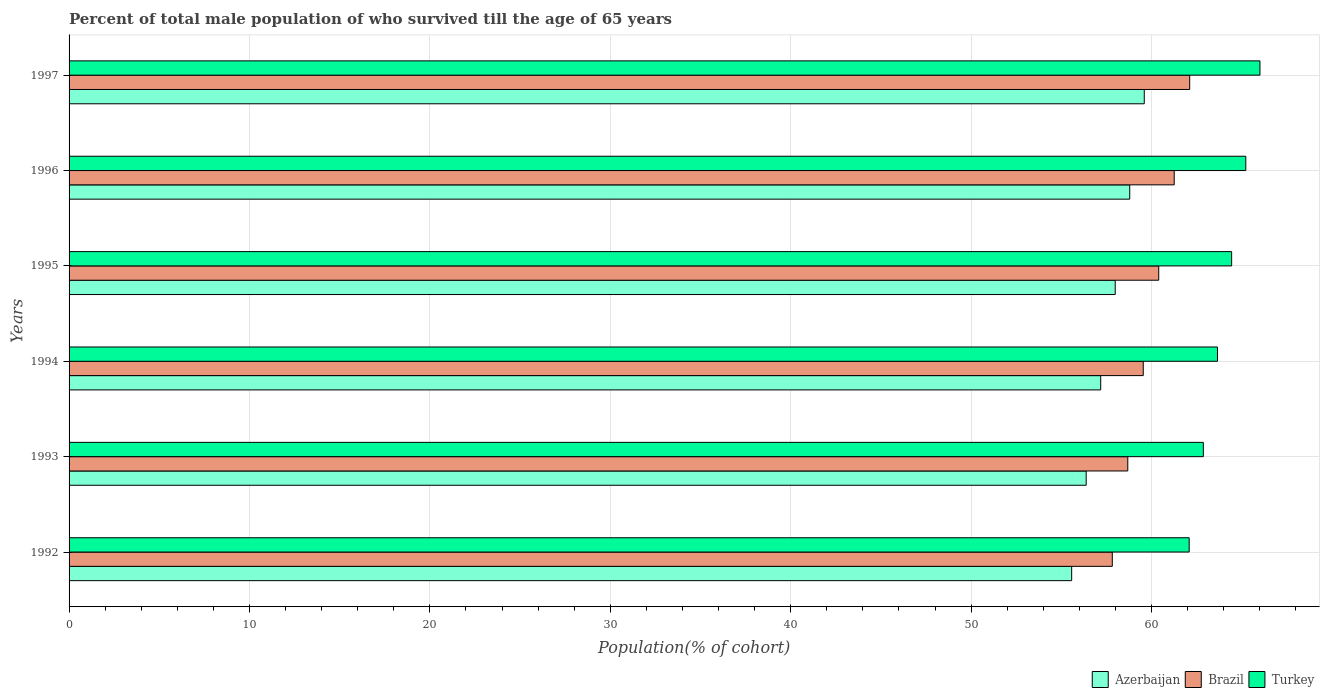How many different coloured bars are there?
Your response must be concise. 3. Are the number of bars per tick equal to the number of legend labels?
Make the answer very short. Yes. What is the percentage of total male population who survived till the age of 65 years in Brazil in 1993?
Ensure brevity in your answer.  58.68. Across all years, what is the maximum percentage of total male population who survived till the age of 65 years in Brazil?
Your answer should be compact. 62.12. Across all years, what is the minimum percentage of total male population who survived till the age of 65 years in Azerbaijan?
Your answer should be compact. 55.57. In which year was the percentage of total male population who survived till the age of 65 years in Azerbaijan maximum?
Provide a short and direct response. 1997. In which year was the percentage of total male population who survived till the age of 65 years in Azerbaijan minimum?
Keep it short and to the point. 1992. What is the total percentage of total male population who survived till the age of 65 years in Azerbaijan in the graph?
Offer a terse response. 345.51. What is the difference between the percentage of total male population who survived till the age of 65 years in Turkey in 1993 and that in 1996?
Offer a terse response. -2.35. What is the difference between the percentage of total male population who survived till the age of 65 years in Azerbaijan in 1992 and the percentage of total male population who survived till the age of 65 years in Turkey in 1996?
Provide a succinct answer. -9.65. What is the average percentage of total male population who survived till the age of 65 years in Azerbaijan per year?
Your answer should be very brief. 57.59. In the year 1994, what is the difference between the percentage of total male population who survived till the age of 65 years in Turkey and percentage of total male population who survived till the age of 65 years in Brazil?
Give a very brief answer. 4.11. What is the ratio of the percentage of total male population who survived till the age of 65 years in Brazil in 1994 to that in 1997?
Keep it short and to the point. 0.96. What is the difference between the highest and the second highest percentage of total male population who survived till the age of 65 years in Azerbaijan?
Offer a very short reply. 0.8. What is the difference between the highest and the lowest percentage of total male population who survived till the age of 65 years in Brazil?
Provide a succinct answer. 4.29. What does the 1st bar from the top in 1993 represents?
Your response must be concise. Turkey. What does the 2nd bar from the bottom in 1993 represents?
Provide a short and direct response. Brazil. Is it the case that in every year, the sum of the percentage of total male population who survived till the age of 65 years in Brazil and percentage of total male population who survived till the age of 65 years in Turkey is greater than the percentage of total male population who survived till the age of 65 years in Azerbaijan?
Ensure brevity in your answer.  Yes. What is the difference between two consecutive major ticks on the X-axis?
Keep it short and to the point. 10. Where does the legend appear in the graph?
Offer a terse response. Bottom right. What is the title of the graph?
Your response must be concise. Percent of total male population of who survived till the age of 65 years. Does "Korea (Republic)" appear as one of the legend labels in the graph?
Your response must be concise. No. What is the label or title of the X-axis?
Keep it short and to the point. Population(% of cohort). What is the Population(% of cohort) of Azerbaijan in 1992?
Give a very brief answer. 55.57. What is the Population(% of cohort) of Brazil in 1992?
Provide a short and direct response. 57.83. What is the Population(% of cohort) in Turkey in 1992?
Keep it short and to the point. 62.09. What is the Population(% of cohort) of Azerbaijan in 1993?
Provide a short and direct response. 56.38. What is the Population(% of cohort) in Brazil in 1993?
Make the answer very short. 58.68. What is the Population(% of cohort) of Turkey in 1993?
Your answer should be very brief. 62.87. What is the Population(% of cohort) of Azerbaijan in 1994?
Provide a short and direct response. 57.18. What is the Population(% of cohort) in Brazil in 1994?
Ensure brevity in your answer.  59.54. What is the Population(% of cohort) in Turkey in 1994?
Keep it short and to the point. 63.66. What is the Population(% of cohort) of Azerbaijan in 1995?
Make the answer very short. 57.99. What is the Population(% of cohort) in Brazil in 1995?
Keep it short and to the point. 60.4. What is the Population(% of cohort) in Turkey in 1995?
Your response must be concise. 64.44. What is the Population(% of cohort) in Azerbaijan in 1996?
Your answer should be compact. 58.79. What is the Population(% of cohort) of Brazil in 1996?
Offer a terse response. 61.26. What is the Population(% of cohort) in Turkey in 1996?
Provide a short and direct response. 65.23. What is the Population(% of cohort) of Azerbaijan in 1997?
Offer a terse response. 59.6. What is the Population(% of cohort) of Brazil in 1997?
Offer a very short reply. 62.12. What is the Population(% of cohort) of Turkey in 1997?
Offer a terse response. 66.01. Across all years, what is the maximum Population(% of cohort) of Azerbaijan?
Your answer should be compact. 59.6. Across all years, what is the maximum Population(% of cohort) in Brazil?
Give a very brief answer. 62.12. Across all years, what is the maximum Population(% of cohort) of Turkey?
Provide a succinct answer. 66.01. Across all years, what is the minimum Population(% of cohort) of Azerbaijan?
Your answer should be very brief. 55.57. Across all years, what is the minimum Population(% of cohort) of Brazil?
Make the answer very short. 57.83. Across all years, what is the minimum Population(% of cohort) in Turkey?
Provide a succinct answer. 62.09. What is the total Population(% of cohort) in Azerbaijan in the graph?
Your response must be concise. 345.51. What is the total Population(% of cohort) in Brazil in the graph?
Make the answer very short. 359.82. What is the total Population(% of cohort) in Turkey in the graph?
Your response must be concise. 384.29. What is the difference between the Population(% of cohort) of Azerbaijan in 1992 and that in 1993?
Offer a terse response. -0.8. What is the difference between the Population(% of cohort) of Brazil in 1992 and that in 1993?
Keep it short and to the point. -0.86. What is the difference between the Population(% of cohort) of Turkey in 1992 and that in 1993?
Your answer should be compact. -0.78. What is the difference between the Population(% of cohort) of Azerbaijan in 1992 and that in 1994?
Make the answer very short. -1.61. What is the difference between the Population(% of cohort) of Brazil in 1992 and that in 1994?
Your answer should be very brief. -1.72. What is the difference between the Population(% of cohort) of Turkey in 1992 and that in 1994?
Make the answer very short. -1.57. What is the difference between the Population(% of cohort) in Azerbaijan in 1992 and that in 1995?
Your answer should be very brief. -2.41. What is the difference between the Population(% of cohort) in Brazil in 1992 and that in 1995?
Make the answer very short. -2.57. What is the difference between the Population(% of cohort) in Turkey in 1992 and that in 1995?
Keep it short and to the point. -2.35. What is the difference between the Population(% of cohort) in Azerbaijan in 1992 and that in 1996?
Keep it short and to the point. -3.22. What is the difference between the Population(% of cohort) in Brazil in 1992 and that in 1996?
Give a very brief answer. -3.43. What is the difference between the Population(% of cohort) of Turkey in 1992 and that in 1996?
Provide a succinct answer. -3.14. What is the difference between the Population(% of cohort) of Azerbaijan in 1992 and that in 1997?
Give a very brief answer. -4.02. What is the difference between the Population(% of cohort) of Brazil in 1992 and that in 1997?
Offer a very short reply. -4.29. What is the difference between the Population(% of cohort) of Turkey in 1992 and that in 1997?
Give a very brief answer. -3.92. What is the difference between the Population(% of cohort) in Azerbaijan in 1993 and that in 1994?
Provide a succinct answer. -0.8. What is the difference between the Population(% of cohort) of Brazil in 1993 and that in 1994?
Your response must be concise. -0.86. What is the difference between the Population(% of cohort) of Turkey in 1993 and that in 1994?
Offer a terse response. -0.78. What is the difference between the Population(% of cohort) in Azerbaijan in 1993 and that in 1995?
Keep it short and to the point. -1.61. What is the difference between the Population(% of cohort) in Brazil in 1993 and that in 1995?
Provide a succinct answer. -1.72. What is the difference between the Population(% of cohort) of Turkey in 1993 and that in 1995?
Keep it short and to the point. -1.57. What is the difference between the Population(% of cohort) of Azerbaijan in 1993 and that in 1996?
Provide a short and direct response. -2.41. What is the difference between the Population(% of cohort) of Brazil in 1993 and that in 1996?
Keep it short and to the point. -2.57. What is the difference between the Population(% of cohort) in Turkey in 1993 and that in 1996?
Your response must be concise. -2.35. What is the difference between the Population(% of cohort) in Azerbaijan in 1993 and that in 1997?
Keep it short and to the point. -3.22. What is the difference between the Population(% of cohort) of Brazil in 1993 and that in 1997?
Give a very brief answer. -3.43. What is the difference between the Population(% of cohort) of Turkey in 1993 and that in 1997?
Make the answer very short. -3.14. What is the difference between the Population(% of cohort) in Azerbaijan in 1994 and that in 1995?
Offer a terse response. -0.8. What is the difference between the Population(% of cohort) of Brazil in 1994 and that in 1995?
Ensure brevity in your answer.  -0.86. What is the difference between the Population(% of cohort) in Turkey in 1994 and that in 1995?
Give a very brief answer. -0.78. What is the difference between the Population(% of cohort) in Azerbaijan in 1994 and that in 1996?
Provide a succinct answer. -1.61. What is the difference between the Population(% of cohort) in Brazil in 1994 and that in 1996?
Your answer should be compact. -1.72. What is the difference between the Population(% of cohort) of Turkey in 1994 and that in 1996?
Your response must be concise. -1.57. What is the difference between the Population(% of cohort) in Azerbaijan in 1994 and that in 1997?
Offer a terse response. -2.41. What is the difference between the Population(% of cohort) in Brazil in 1994 and that in 1997?
Your response must be concise. -2.57. What is the difference between the Population(% of cohort) in Turkey in 1994 and that in 1997?
Provide a succinct answer. -2.35. What is the difference between the Population(% of cohort) in Azerbaijan in 1995 and that in 1996?
Give a very brief answer. -0.8. What is the difference between the Population(% of cohort) of Brazil in 1995 and that in 1996?
Keep it short and to the point. -0.86. What is the difference between the Population(% of cohort) in Turkey in 1995 and that in 1996?
Your answer should be compact. -0.78. What is the difference between the Population(% of cohort) in Azerbaijan in 1995 and that in 1997?
Keep it short and to the point. -1.61. What is the difference between the Population(% of cohort) of Brazil in 1995 and that in 1997?
Provide a succinct answer. -1.72. What is the difference between the Population(% of cohort) of Turkey in 1995 and that in 1997?
Provide a short and direct response. -1.57. What is the difference between the Population(% of cohort) in Azerbaijan in 1996 and that in 1997?
Your response must be concise. -0.8. What is the difference between the Population(% of cohort) of Brazil in 1996 and that in 1997?
Provide a succinct answer. -0.86. What is the difference between the Population(% of cohort) in Turkey in 1996 and that in 1997?
Make the answer very short. -0.78. What is the difference between the Population(% of cohort) in Azerbaijan in 1992 and the Population(% of cohort) in Brazil in 1993?
Offer a terse response. -3.11. What is the difference between the Population(% of cohort) in Azerbaijan in 1992 and the Population(% of cohort) in Turkey in 1993?
Provide a short and direct response. -7.3. What is the difference between the Population(% of cohort) of Brazil in 1992 and the Population(% of cohort) of Turkey in 1993?
Your answer should be compact. -5.05. What is the difference between the Population(% of cohort) of Azerbaijan in 1992 and the Population(% of cohort) of Brazil in 1994?
Offer a very short reply. -3.97. What is the difference between the Population(% of cohort) of Azerbaijan in 1992 and the Population(% of cohort) of Turkey in 1994?
Make the answer very short. -8.08. What is the difference between the Population(% of cohort) in Brazil in 1992 and the Population(% of cohort) in Turkey in 1994?
Provide a succinct answer. -5.83. What is the difference between the Population(% of cohort) in Azerbaijan in 1992 and the Population(% of cohort) in Brazil in 1995?
Your answer should be compact. -4.83. What is the difference between the Population(% of cohort) in Azerbaijan in 1992 and the Population(% of cohort) in Turkey in 1995?
Ensure brevity in your answer.  -8.87. What is the difference between the Population(% of cohort) of Brazil in 1992 and the Population(% of cohort) of Turkey in 1995?
Give a very brief answer. -6.62. What is the difference between the Population(% of cohort) of Azerbaijan in 1992 and the Population(% of cohort) of Brazil in 1996?
Ensure brevity in your answer.  -5.68. What is the difference between the Population(% of cohort) of Azerbaijan in 1992 and the Population(% of cohort) of Turkey in 1996?
Ensure brevity in your answer.  -9.65. What is the difference between the Population(% of cohort) of Brazil in 1992 and the Population(% of cohort) of Turkey in 1996?
Keep it short and to the point. -7.4. What is the difference between the Population(% of cohort) in Azerbaijan in 1992 and the Population(% of cohort) in Brazil in 1997?
Offer a terse response. -6.54. What is the difference between the Population(% of cohort) of Azerbaijan in 1992 and the Population(% of cohort) of Turkey in 1997?
Provide a succinct answer. -10.44. What is the difference between the Population(% of cohort) in Brazil in 1992 and the Population(% of cohort) in Turkey in 1997?
Your response must be concise. -8.18. What is the difference between the Population(% of cohort) in Azerbaijan in 1993 and the Population(% of cohort) in Brazil in 1994?
Offer a terse response. -3.16. What is the difference between the Population(% of cohort) of Azerbaijan in 1993 and the Population(% of cohort) of Turkey in 1994?
Offer a terse response. -7.28. What is the difference between the Population(% of cohort) of Brazil in 1993 and the Population(% of cohort) of Turkey in 1994?
Keep it short and to the point. -4.97. What is the difference between the Population(% of cohort) in Azerbaijan in 1993 and the Population(% of cohort) in Brazil in 1995?
Ensure brevity in your answer.  -4.02. What is the difference between the Population(% of cohort) of Azerbaijan in 1993 and the Population(% of cohort) of Turkey in 1995?
Offer a very short reply. -8.06. What is the difference between the Population(% of cohort) in Brazil in 1993 and the Population(% of cohort) in Turkey in 1995?
Keep it short and to the point. -5.76. What is the difference between the Population(% of cohort) of Azerbaijan in 1993 and the Population(% of cohort) of Brazil in 1996?
Provide a succinct answer. -4.88. What is the difference between the Population(% of cohort) of Azerbaijan in 1993 and the Population(% of cohort) of Turkey in 1996?
Offer a very short reply. -8.85. What is the difference between the Population(% of cohort) of Brazil in 1993 and the Population(% of cohort) of Turkey in 1996?
Ensure brevity in your answer.  -6.54. What is the difference between the Population(% of cohort) of Azerbaijan in 1993 and the Population(% of cohort) of Brazil in 1997?
Make the answer very short. -5.74. What is the difference between the Population(% of cohort) in Azerbaijan in 1993 and the Population(% of cohort) in Turkey in 1997?
Your answer should be very brief. -9.63. What is the difference between the Population(% of cohort) in Brazil in 1993 and the Population(% of cohort) in Turkey in 1997?
Your response must be concise. -7.33. What is the difference between the Population(% of cohort) in Azerbaijan in 1994 and the Population(% of cohort) in Brazil in 1995?
Offer a very short reply. -3.22. What is the difference between the Population(% of cohort) of Azerbaijan in 1994 and the Population(% of cohort) of Turkey in 1995?
Your response must be concise. -7.26. What is the difference between the Population(% of cohort) of Brazil in 1994 and the Population(% of cohort) of Turkey in 1995?
Ensure brevity in your answer.  -4.9. What is the difference between the Population(% of cohort) in Azerbaijan in 1994 and the Population(% of cohort) in Brazil in 1996?
Your answer should be very brief. -4.07. What is the difference between the Population(% of cohort) in Azerbaijan in 1994 and the Population(% of cohort) in Turkey in 1996?
Offer a very short reply. -8.04. What is the difference between the Population(% of cohort) of Brazil in 1994 and the Population(% of cohort) of Turkey in 1996?
Provide a succinct answer. -5.68. What is the difference between the Population(% of cohort) in Azerbaijan in 1994 and the Population(% of cohort) in Brazil in 1997?
Offer a very short reply. -4.93. What is the difference between the Population(% of cohort) in Azerbaijan in 1994 and the Population(% of cohort) in Turkey in 1997?
Provide a succinct answer. -8.83. What is the difference between the Population(% of cohort) in Brazil in 1994 and the Population(% of cohort) in Turkey in 1997?
Your response must be concise. -6.47. What is the difference between the Population(% of cohort) of Azerbaijan in 1995 and the Population(% of cohort) of Brazil in 1996?
Your answer should be very brief. -3.27. What is the difference between the Population(% of cohort) in Azerbaijan in 1995 and the Population(% of cohort) in Turkey in 1996?
Offer a terse response. -7.24. What is the difference between the Population(% of cohort) of Brazil in 1995 and the Population(% of cohort) of Turkey in 1996?
Provide a succinct answer. -4.83. What is the difference between the Population(% of cohort) of Azerbaijan in 1995 and the Population(% of cohort) of Brazil in 1997?
Provide a short and direct response. -4.13. What is the difference between the Population(% of cohort) of Azerbaijan in 1995 and the Population(% of cohort) of Turkey in 1997?
Provide a short and direct response. -8.02. What is the difference between the Population(% of cohort) of Brazil in 1995 and the Population(% of cohort) of Turkey in 1997?
Offer a terse response. -5.61. What is the difference between the Population(% of cohort) of Azerbaijan in 1996 and the Population(% of cohort) of Brazil in 1997?
Provide a succinct answer. -3.32. What is the difference between the Population(% of cohort) of Azerbaijan in 1996 and the Population(% of cohort) of Turkey in 1997?
Make the answer very short. -7.22. What is the difference between the Population(% of cohort) of Brazil in 1996 and the Population(% of cohort) of Turkey in 1997?
Your response must be concise. -4.75. What is the average Population(% of cohort) of Azerbaijan per year?
Your answer should be compact. 57.59. What is the average Population(% of cohort) of Brazil per year?
Ensure brevity in your answer.  59.97. What is the average Population(% of cohort) of Turkey per year?
Make the answer very short. 64.05. In the year 1992, what is the difference between the Population(% of cohort) in Azerbaijan and Population(% of cohort) in Brazil?
Offer a terse response. -2.25. In the year 1992, what is the difference between the Population(% of cohort) in Azerbaijan and Population(% of cohort) in Turkey?
Provide a short and direct response. -6.51. In the year 1992, what is the difference between the Population(% of cohort) in Brazil and Population(% of cohort) in Turkey?
Offer a terse response. -4.26. In the year 1993, what is the difference between the Population(% of cohort) in Azerbaijan and Population(% of cohort) in Brazil?
Offer a very short reply. -2.31. In the year 1993, what is the difference between the Population(% of cohort) in Azerbaijan and Population(% of cohort) in Turkey?
Keep it short and to the point. -6.49. In the year 1993, what is the difference between the Population(% of cohort) of Brazil and Population(% of cohort) of Turkey?
Give a very brief answer. -4.19. In the year 1994, what is the difference between the Population(% of cohort) in Azerbaijan and Population(% of cohort) in Brazil?
Keep it short and to the point. -2.36. In the year 1994, what is the difference between the Population(% of cohort) in Azerbaijan and Population(% of cohort) in Turkey?
Your answer should be very brief. -6.47. In the year 1994, what is the difference between the Population(% of cohort) of Brazil and Population(% of cohort) of Turkey?
Offer a terse response. -4.11. In the year 1995, what is the difference between the Population(% of cohort) of Azerbaijan and Population(% of cohort) of Brazil?
Keep it short and to the point. -2.41. In the year 1995, what is the difference between the Population(% of cohort) of Azerbaijan and Population(% of cohort) of Turkey?
Provide a succinct answer. -6.45. In the year 1995, what is the difference between the Population(% of cohort) in Brazil and Population(% of cohort) in Turkey?
Your answer should be very brief. -4.04. In the year 1996, what is the difference between the Population(% of cohort) in Azerbaijan and Population(% of cohort) in Brazil?
Your answer should be very brief. -2.47. In the year 1996, what is the difference between the Population(% of cohort) of Azerbaijan and Population(% of cohort) of Turkey?
Provide a short and direct response. -6.43. In the year 1996, what is the difference between the Population(% of cohort) in Brazil and Population(% of cohort) in Turkey?
Offer a very short reply. -3.97. In the year 1997, what is the difference between the Population(% of cohort) in Azerbaijan and Population(% of cohort) in Brazil?
Ensure brevity in your answer.  -2.52. In the year 1997, what is the difference between the Population(% of cohort) in Azerbaijan and Population(% of cohort) in Turkey?
Make the answer very short. -6.41. In the year 1997, what is the difference between the Population(% of cohort) of Brazil and Population(% of cohort) of Turkey?
Keep it short and to the point. -3.89. What is the ratio of the Population(% of cohort) in Azerbaijan in 1992 to that in 1993?
Offer a very short reply. 0.99. What is the ratio of the Population(% of cohort) in Brazil in 1992 to that in 1993?
Provide a short and direct response. 0.99. What is the ratio of the Population(% of cohort) of Turkey in 1992 to that in 1993?
Provide a succinct answer. 0.99. What is the ratio of the Population(% of cohort) of Azerbaijan in 1992 to that in 1994?
Keep it short and to the point. 0.97. What is the ratio of the Population(% of cohort) of Brazil in 1992 to that in 1994?
Offer a very short reply. 0.97. What is the ratio of the Population(% of cohort) in Turkey in 1992 to that in 1994?
Make the answer very short. 0.98. What is the ratio of the Population(% of cohort) in Azerbaijan in 1992 to that in 1995?
Provide a short and direct response. 0.96. What is the ratio of the Population(% of cohort) in Brazil in 1992 to that in 1995?
Your answer should be compact. 0.96. What is the ratio of the Population(% of cohort) of Turkey in 1992 to that in 1995?
Your answer should be compact. 0.96. What is the ratio of the Population(% of cohort) of Azerbaijan in 1992 to that in 1996?
Keep it short and to the point. 0.95. What is the ratio of the Population(% of cohort) in Brazil in 1992 to that in 1996?
Offer a very short reply. 0.94. What is the ratio of the Population(% of cohort) of Turkey in 1992 to that in 1996?
Make the answer very short. 0.95. What is the ratio of the Population(% of cohort) in Azerbaijan in 1992 to that in 1997?
Offer a very short reply. 0.93. What is the ratio of the Population(% of cohort) of Brazil in 1992 to that in 1997?
Provide a succinct answer. 0.93. What is the ratio of the Population(% of cohort) in Turkey in 1992 to that in 1997?
Provide a succinct answer. 0.94. What is the ratio of the Population(% of cohort) in Azerbaijan in 1993 to that in 1994?
Provide a succinct answer. 0.99. What is the ratio of the Population(% of cohort) in Brazil in 1993 to that in 1994?
Your answer should be very brief. 0.99. What is the ratio of the Population(% of cohort) of Turkey in 1993 to that in 1994?
Your answer should be very brief. 0.99. What is the ratio of the Population(% of cohort) of Azerbaijan in 1993 to that in 1995?
Provide a succinct answer. 0.97. What is the ratio of the Population(% of cohort) in Brazil in 1993 to that in 1995?
Your response must be concise. 0.97. What is the ratio of the Population(% of cohort) of Turkey in 1993 to that in 1995?
Your answer should be very brief. 0.98. What is the ratio of the Population(% of cohort) of Azerbaijan in 1993 to that in 1996?
Give a very brief answer. 0.96. What is the ratio of the Population(% of cohort) in Brazil in 1993 to that in 1996?
Give a very brief answer. 0.96. What is the ratio of the Population(% of cohort) of Turkey in 1993 to that in 1996?
Provide a succinct answer. 0.96. What is the ratio of the Population(% of cohort) in Azerbaijan in 1993 to that in 1997?
Provide a short and direct response. 0.95. What is the ratio of the Population(% of cohort) of Brazil in 1993 to that in 1997?
Offer a terse response. 0.94. What is the ratio of the Population(% of cohort) in Turkey in 1993 to that in 1997?
Your response must be concise. 0.95. What is the ratio of the Population(% of cohort) in Azerbaijan in 1994 to that in 1995?
Provide a succinct answer. 0.99. What is the ratio of the Population(% of cohort) in Brazil in 1994 to that in 1995?
Your answer should be compact. 0.99. What is the ratio of the Population(% of cohort) in Turkey in 1994 to that in 1995?
Make the answer very short. 0.99. What is the ratio of the Population(% of cohort) of Azerbaijan in 1994 to that in 1996?
Your answer should be very brief. 0.97. What is the ratio of the Population(% of cohort) of Brazil in 1994 to that in 1996?
Provide a succinct answer. 0.97. What is the ratio of the Population(% of cohort) in Turkey in 1994 to that in 1996?
Your answer should be very brief. 0.98. What is the ratio of the Population(% of cohort) in Azerbaijan in 1994 to that in 1997?
Offer a terse response. 0.96. What is the ratio of the Population(% of cohort) in Brazil in 1994 to that in 1997?
Ensure brevity in your answer.  0.96. What is the ratio of the Population(% of cohort) in Azerbaijan in 1995 to that in 1996?
Your response must be concise. 0.99. What is the ratio of the Population(% of cohort) of Turkey in 1995 to that in 1996?
Offer a terse response. 0.99. What is the ratio of the Population(% of cohort) of Azerbaijan in 1995 to that in 1997?
Your response must be concise. 0.97. What is the ratio of the Population(% of cohort) in Brazil in 1995 to that in 1997?
Keep it short and to the point. 0.97. What is the ratio of the Population(% of cohort) in Turkey in 1995 to that in 1997?
Offer a terse response. 0.98. What is the ratio of the Population(% of cohort) in Azerbaijan in 1996 to that in 1997?
Offer a terse response. 0.99. What is the ratio of the Population(% of cohort) in Brazil in 1996 to that in 1997?
Make the answer very short. 0.99. What is the ratio of the Population(% of cohort) of Turkey in 1996 to that in 1997?
Provide a succinct answer. 0.99. What is the difference between the highest and the second highest Population(% of cohort) of Azerbaijan?
Offer a very short reply. 0.8. What is the difference between the highest and the second highest Population(% of cohort) in Brazil?
Make the answer very short. 0.86. What is the difference between the highest and the second highest Population(% of cohort) in Turkey?
Your answer should be very brief. 0.78. What is the difference between the highest and the lowest Population(% of cohort) of Azerbaijan?
Provide a succinct answer. 4.02. What is the difference between the highest and the lowest Population(% of cohort) in Brazil?
Offer a very short reply. 4.29. What is the difference between the highest and the lowest Population(% of cohort) in Turkey?
Your answer should be very brief. 3.92. 